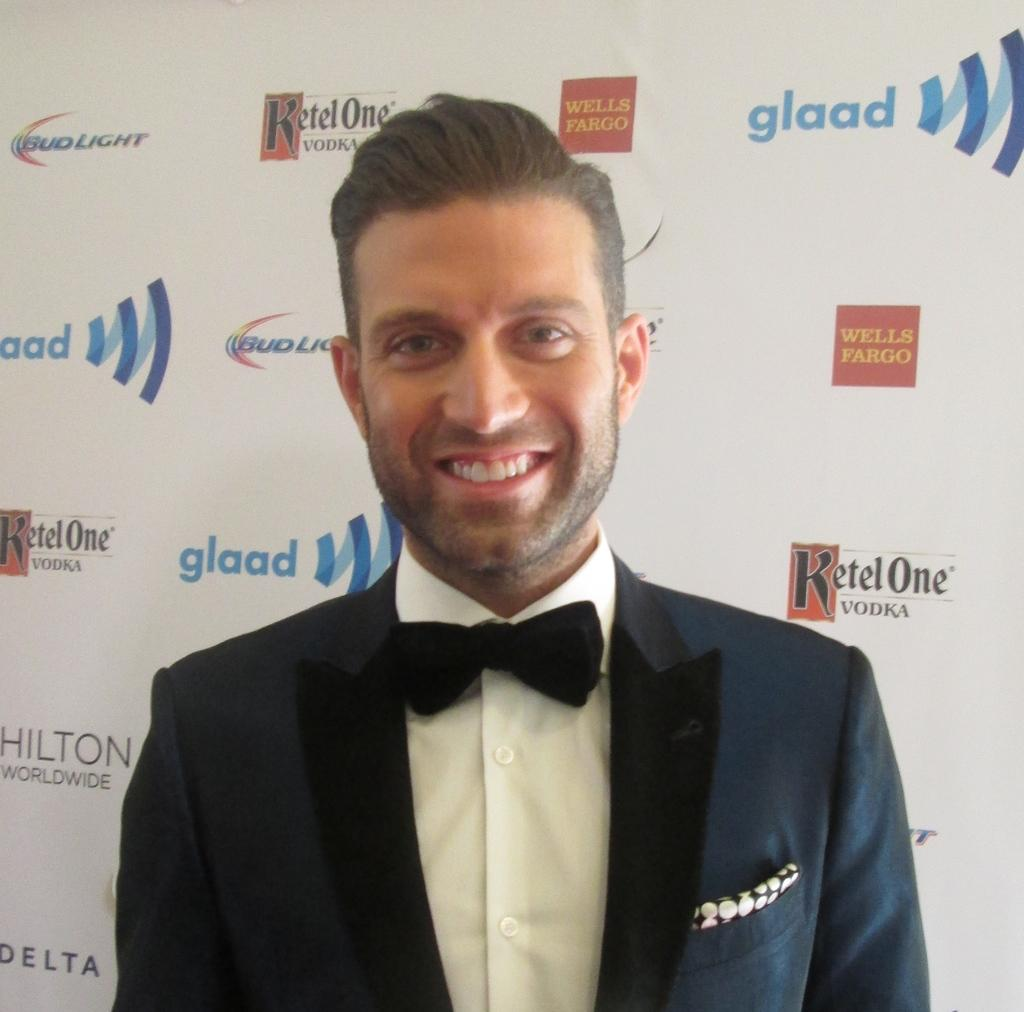Who is the main subject in the image? There is a man in the image. What is the man wearing? The man is wearing a black suit and a white shirt. What is the man's facial expression in the image? The man is smiling. What is the man doing in the image? The man is giving a pose to the camera. What is the background of the image? There is a white background in the image. What type of disease can be seen affecting the man in the image? There is no disease present in the image; the man appears healthy and is smiling. What type of lamp is visible on the man's head in the image? There is no lamp present in the image; the man is wearing a suit and a white shirt. 